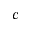<formula> <loc_0><loc_0><loc_500><loc_500>c</formula> 